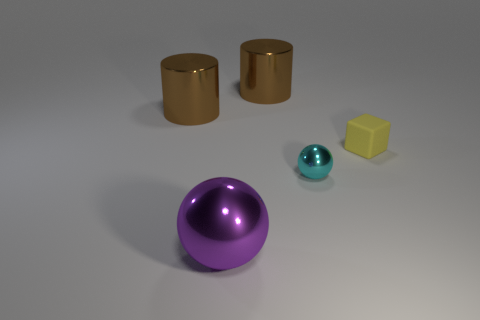Add 2 cyan shiny balls. How many objects exist? 7 Subtract all blocks. How many objects are left? 4 Add 5 cyan metallic things. How many cyan metallic things exist? 6 Subtract 0 brown balls. How many objects are left? 5 Subtract all yellow rubber cubes. Subtract all matte objects. How many objects are left? 3 Add 1 small cyan spheres. How many small cyan spheres are left? 2 